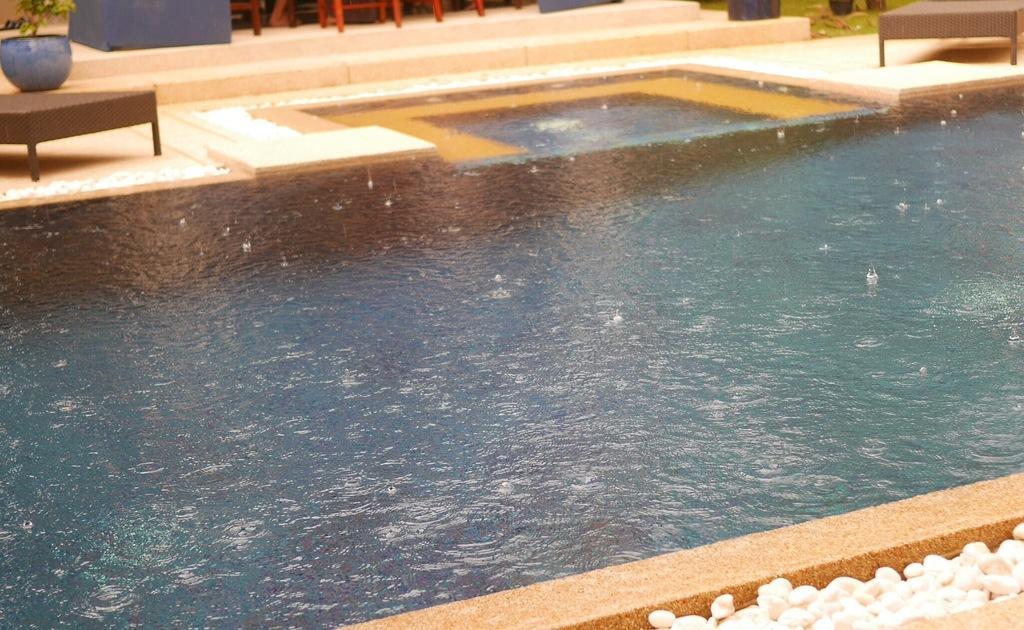In one or two sentences, can you explain what this image depicts? In the center of the image we can see a swimming pool. In the background there are tables and we can see flower pot. At the bottom there are stones. 